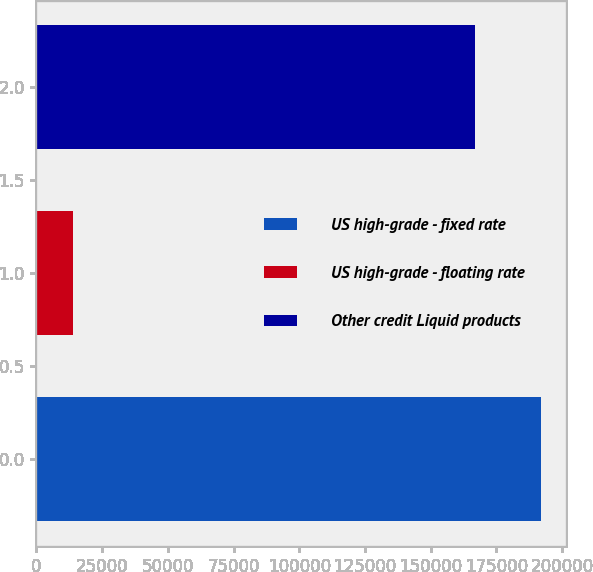Convert chart. <chart><loc_0><loc_0><loc_500><loc_500><bar_chart><fcel>US high-grade - fixed rate<fcel>US high-grade - floating rate<fcel>Other credit Liquid products<nl><fcel>191950<fcel>14066<fcel>166990<nl></chart> 